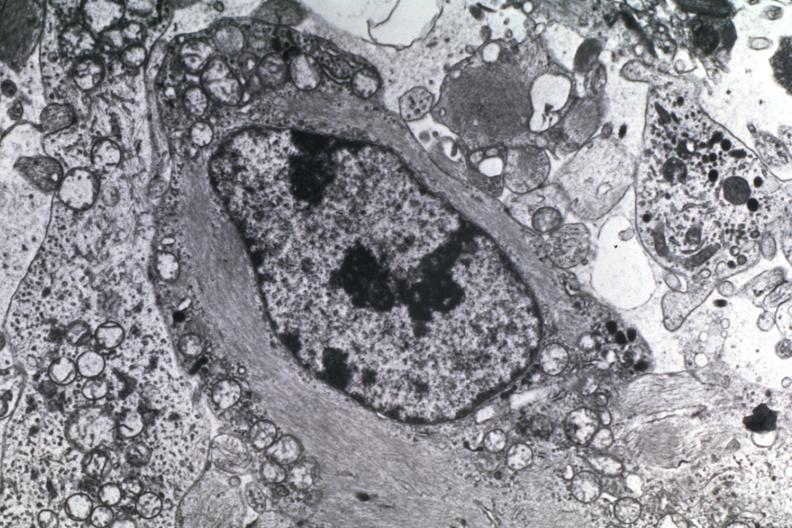does atrophy secondary to pituitectomy show dr garcia tumors 5?
Answer the question using a single word or phrase. No 